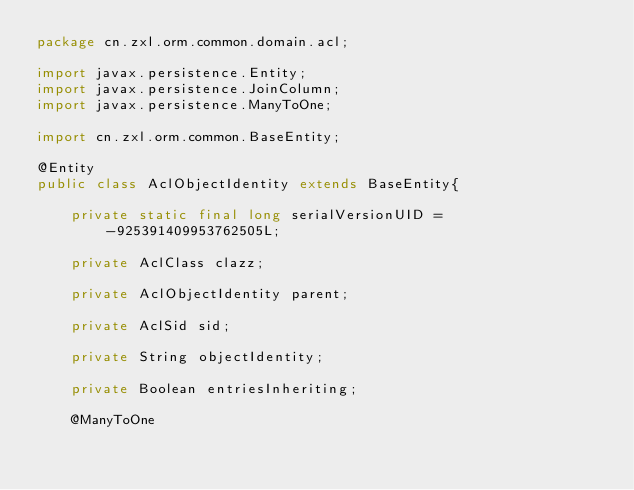<code> <loc_0><loc_0><loc_500><loc_500><_Java_>package cn.zxl.orm.common.domain.acl;

import javax.persistence.Entity;
import javax.persistence.JoinColumn;
import javax.persistence.ManyToOne;

import cn.zxl.orm.common.BaseEntity;

@Entity
public class AclObjectIdentity extends BaseEntity{

	private static final long serialVersionUID = -925391409953762505L;

	private AclClass clazz;
	
	private AclObjectIdentity parent;
	
	private AclSid sid;
	
	private String objectIdentity;
	
	private Boolean entriesInheriting;
	
	@ManyToOne</code> 